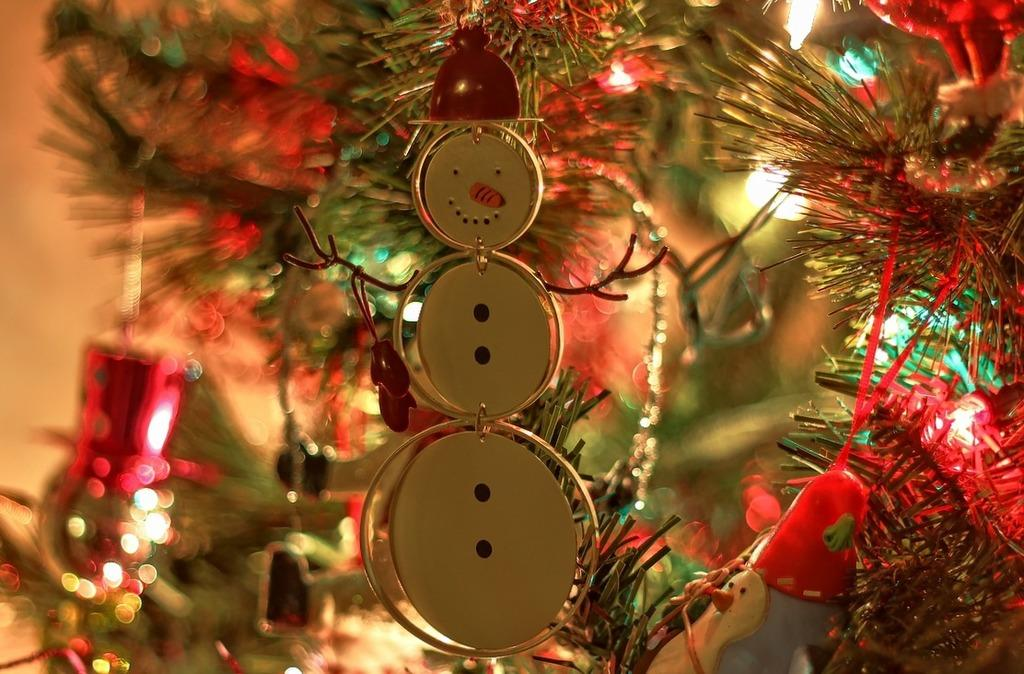What types of objects can be seen in the image? There are decorative objects in the image. Can you describe one of the objects in the image? There is a silver-colored object in the image. What can be seen in the background of the image? There is lighting in the background of the image. How many bears can be seen in the image? There are no bears present in the image. What type of view is visible through the window in the image? There is no window or view visible in the image. 